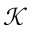Convert formula to latex. <formula><loc_0><loc_0><loc_500><loc_500>\mathcal { K }</formula> 